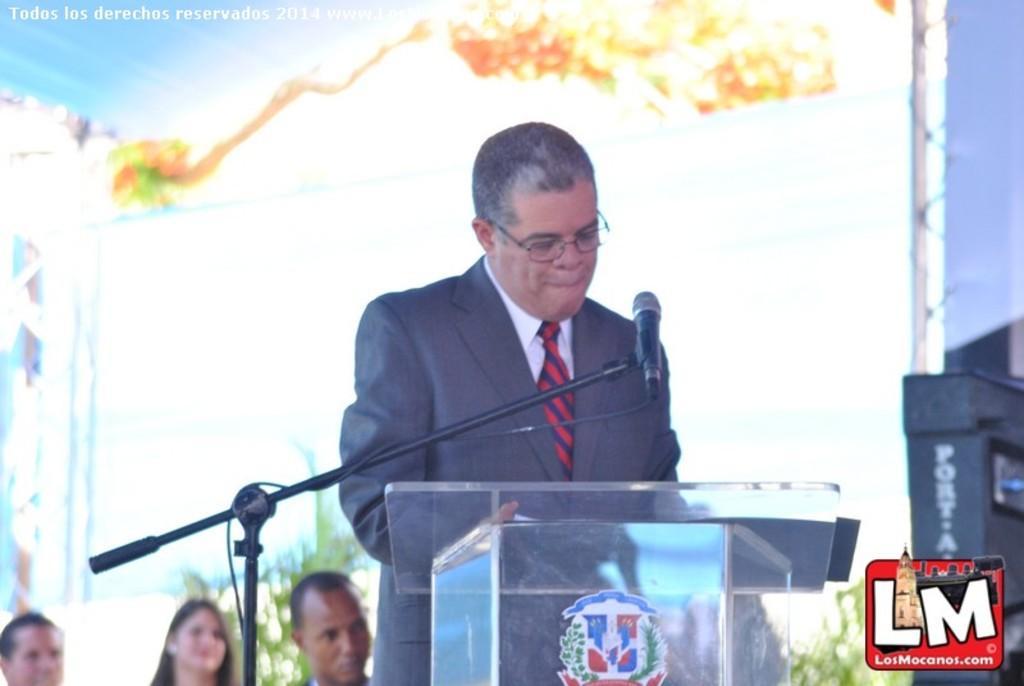Describe this image in one or two sentences. In this picture we can see a man is standing behind the podium and on the left side of the podium there is a microphone with stand. Behind the man there are three people, trees and other objects and on the image there are watermarks. 